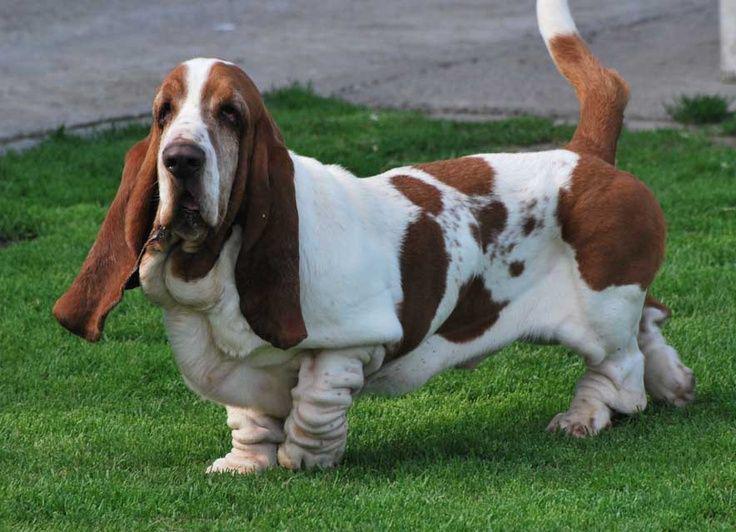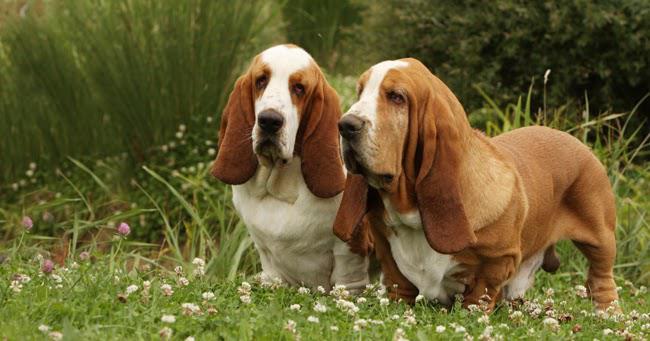The first image is the image on the left, the second image is the image on the right. For the images displayed, is the sentence "Exactly three bassett hounds are pictured, two of them side by side." factually correct? Answer yes or no. Yes. The first image is the image on the left, the second image is the image on the right. Examine the images to the left and right. Is the description "There are three dogs" accurate? Answer yes or no. Yes. 